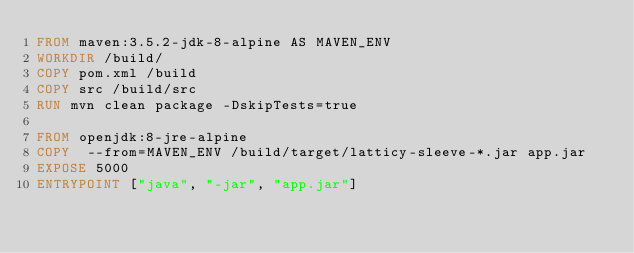Convert code to text. <code><loc_0><loc_0><loc_500><loc_500><_Dockerfile_>FROM maven:3.5.2-jdk-8-alpine AS MAVEN_ENV
WORKDIR /build/
COPY pom.xml /build
COPY src /build/src
RUN mvn clean package -DskipTests=true

FROM openjdk:8-jre-alpine
COPY  --from=MAVEN_ENV /build/target/latticy-sleeve-*.jar app.jar
EXPOSE 5000
ENTRYPOINT ["java", "-jar", "app.jar"]</code> 